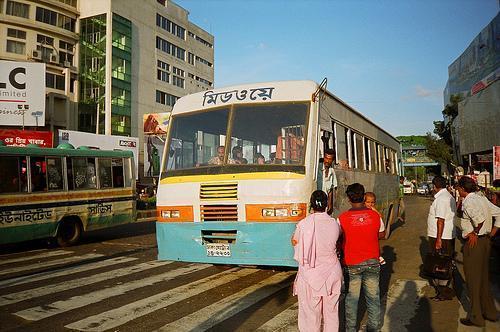How many buses are pictured?
Give a very brief answer. 2. How many colored bus vents are pictured?
Give a very brief answer. 2. 